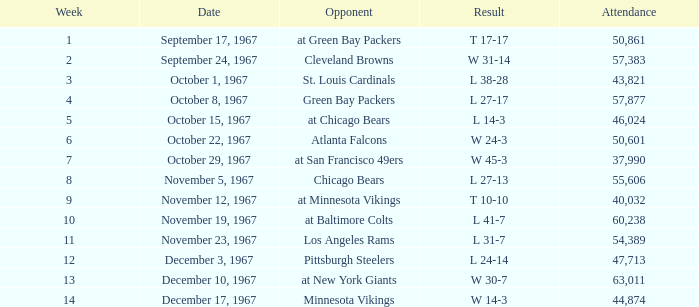On which date is there a week shorter than 8, and a rival of atlanta falcons? October 22, 1967. 